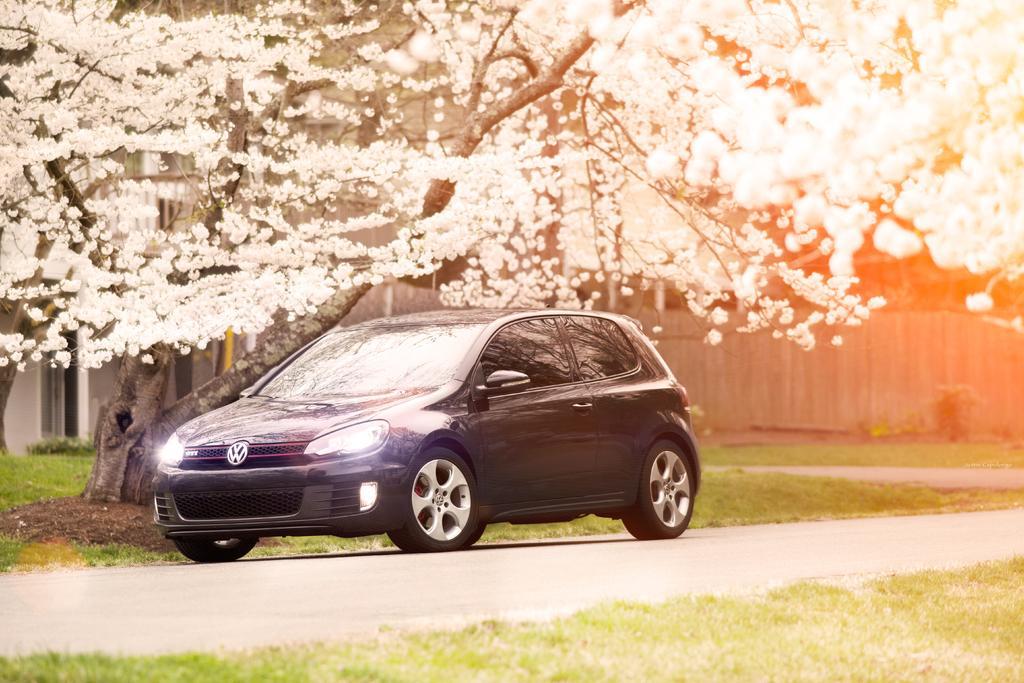Can you describe this image briefly? In this picture there is a black color car on the road. At the back there is a building and there is a wooden railing and there are trees and there are white color flowers on the tree. At the bottom there is grass and there is a road. 